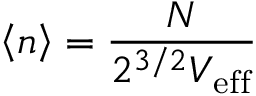Convert formula to latex. <formula><loc_0><loc_0><loc_500><loc_500>\left < n \right > = \frac { N } { 2 ^ { 3 / 2 } V _ { e f f } }</formula> 